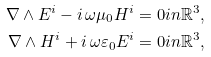<formula> <loc_0><loc_0><loc_500><loc_500>\nabla \wedge E ^ { i } - i \, \omega \mu _ { 0 } H ^ { i } & = 0 i n \mathbb { R } ^ { 3 } , \\ \nabla \wedge H ^ { i } + i \, \omega \varepsilon _ { 0 } E ^ { i } & = 0 i n \mathbb { R } ^ { 3 } ,</formula> 